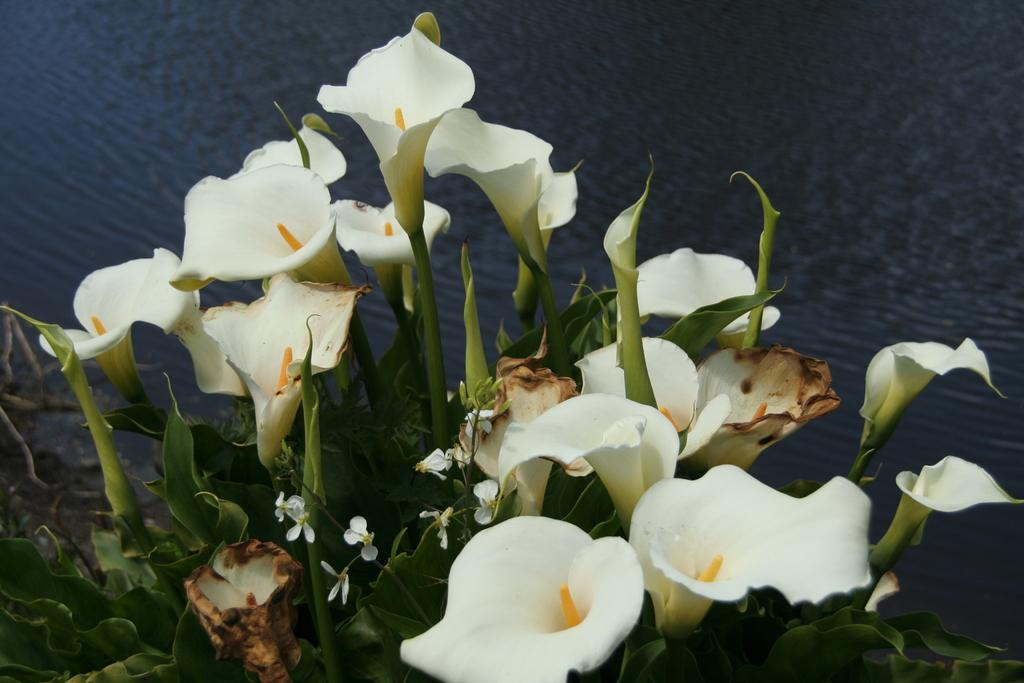What type of plants are present in the image? There are plants with flowers in the image. What can be seen behind the flowers in the image? There is water visible behind the flowers in the image. What type of oven is visible in the image? There is no oven present in the image. What type of cap is being worn by the plants in the image? The plants in the image do not have caps, as they are not people or animals. 